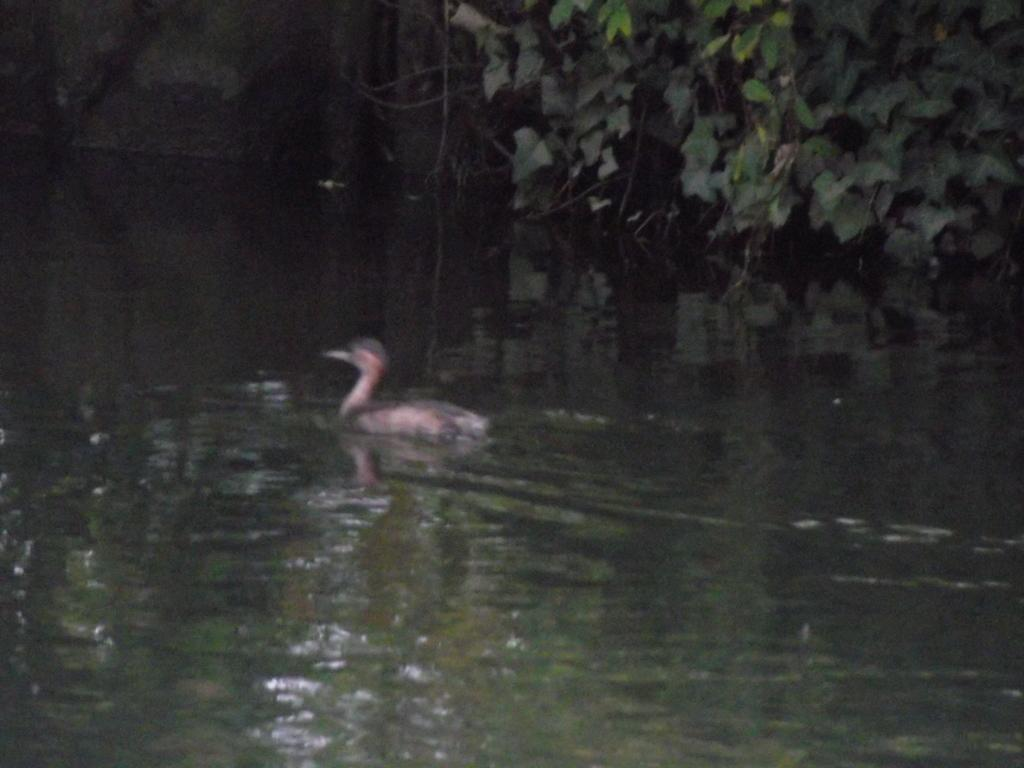What animal can be seen in the image? There is a duck in the image. What is the duck doing in the image? The duck is swimming on the water. What other elements can be seen in the image besides the duck? There are leaves of a plant visible in the top right of the image. What is the rate at which the duck is brushing its feathers in the image? There is no indication in the image that the duck is brushing its feathers, and therefore no rate can be determined. 